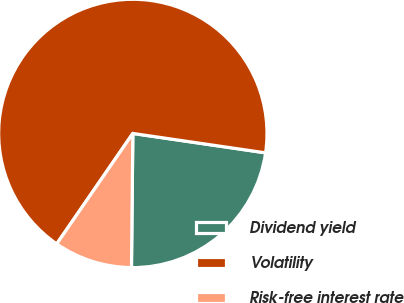<chart> <loc_0><loc_0><loc_500><loc_500><pie_chart><fcel>Dividend yield<fcel>Volatility<fcel>Risk-free interest rate<nl><fcel>22.85%<fcel>67.7%<fcel>9.44%<nl></chart> 